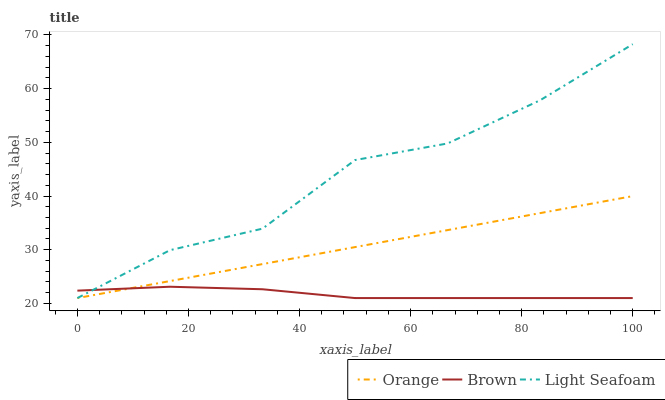Does Brown have the minimum area under the curve?
Answer yes or no. Yes. Does Light Seafoam have the maximum area under the curve?
Answer yes or no. Yes. Does Light Seafoam have the minimum area under the curve?
Answer yes or no. No. Does Brown have the maximum area under the curve?
Answer yes or no. No. Is Orange the smoothest?
Answer yes or no. Yes. Is Light Seafoam the roughest?
Answer yes or no. Yes. Is Brown the smoothest?
Answer yes or no. No. Is Brown the roughest?
Answer yes or no. No. Does Orange have the lowest value?
Answer yes or no. Yes. Does Light Seafoam have the highest value?
Answer yes or no. Yes. Does Brown have the highest value?
Answer yes or no. No. Does Orange intersect Brown?
Answer yes or no. Yes. Is Orange less than Brown?
Answer yes or no. No. Is Orange greater than Brown?
Answer yes or no. No. 